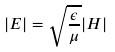Convert formula to latex. <formula><loc_0><loc_0><loc_500><loc_500>| E | = \sqrt { \frac { \epsilon } { \mu } } | H |</formula> 